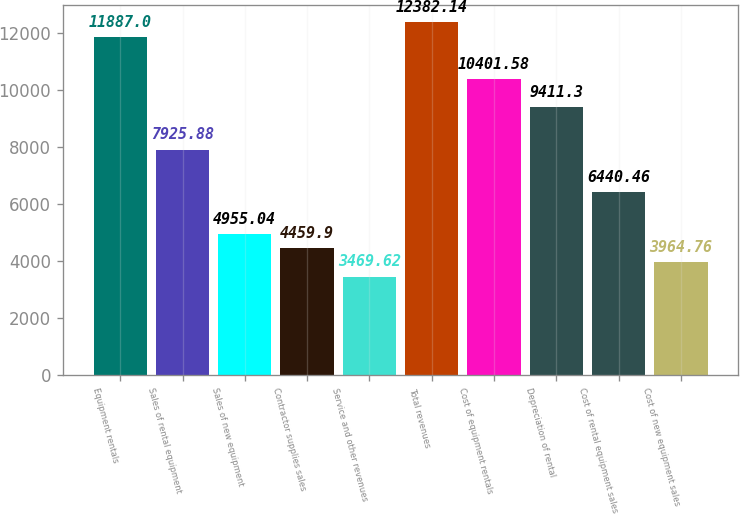<chart> <loc_0><loc_0><loc_500><loc_500><bar_chart><fcel>Equipment rentals<fcel>Sales of rental equipment<fcel>Sales of new equipment<fcel>Contractor supplies sales<fcel>Service and other revenues<fcel>Total revenues<fcel>Cost of equipment rentals<fcel>Depreciation of rental<fcel>Cost of rental equipment sales<fcel>Cost of new equipment sales<nl><fcel>11887<fcel>7925.88<fcel>4955.04<fcel>4459.9<fcel>3469.62<fcel>12382.1<fcel>10401.6<fcel>9411.3<fcel>6440.46<fcel>3964.76<nl></chart> 